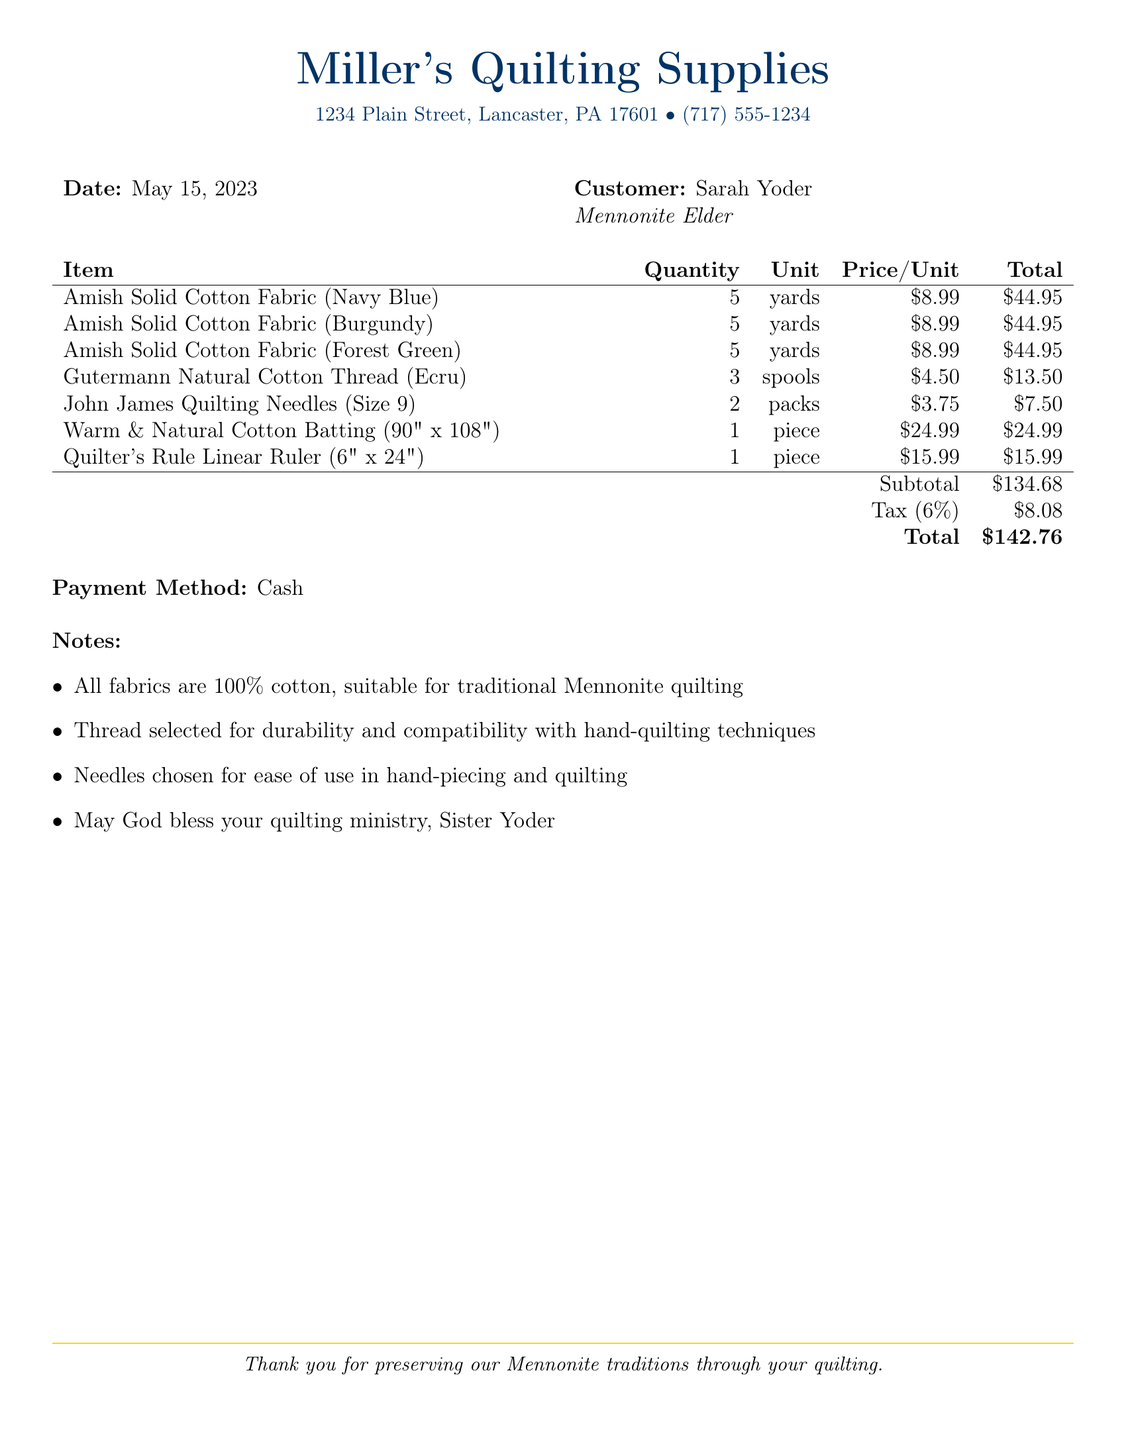What is the vendor's name? The vendor's name is listed at the top of the document as Miller's Quilting Supplies.
Answer: Miller's Quilting Supplies What is the date of the transaction? The date is provided in the document, specifically noted after the vendor information.
Answer: May 15, 2023 How many yards of Navy Blue fabric were purchased? The quantity of Navy Blue fabric is detailed in the items section of the document.
Answer: 5 What is the total amount charged including tax? The total amount is summarized at the bottom of the itemized list in the document.
Answer: $142.76 What payment method was used for the purchase? The payment method is indicated towards the end of the document.
Answer: Cash What is the quantity of Gutermann Natural Cotton Thread purchased? The quantity of thread purchased can be found in the itemized list.
Answer: 3 spools Why were specific needles chosen for the purchase? The document provides notes highlighting the reasons for each item choice, including the needles.
Answer: Ease of use in hand-piecing and quilting What note is included for Sister Yoder? A specific note addressed to Sister Yoder is included towards the end of the document.
Answer: May God bless your quilting ministry, Sister Yoder What type of fabric is mentioned in the notes? The notes specify the type of fabric included in the purchase.
Answer: 100% cotton 